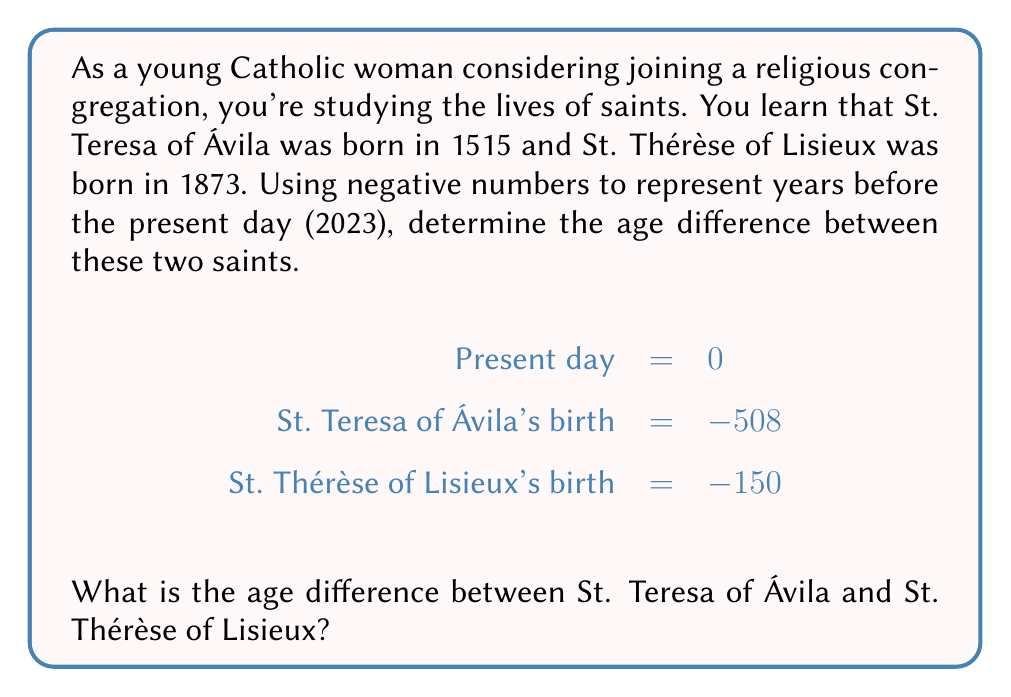Solve this math problem. Let's approach this step-by-step:

1) First, we need to understand that the more negative a number is, the further in the past it represents.

2) We're given:
   St. Teresa of Ávila's birth year: $-508$
   St. Thérèse of Lisieux's birth year: $-150$

3) To find the age difference, we need to subtract the more recent birth year from the earlier birth year:

   $$\text{Age difference} = -508 - (-150)$$

4) When subtracting a negative number, we can rewrite it as addition:

   $$\text{Age difference} = -508 + 150$$

5) Now we can perform the addition:

   $$\text{Age difference} = -358$$

6) The negative sign indicates that St. Teresa of Ávila was born 358 years before St. Thérèse of Lisieux.

7) To express this as a positive number, we can take the absolute value:

   $$\text{Age difference} = |-358| = 358$$

Therefore, the age difference between St. Teresa of Ávila and St. Thérèse of Lisieux is 358 years.
Answer: 358 years 